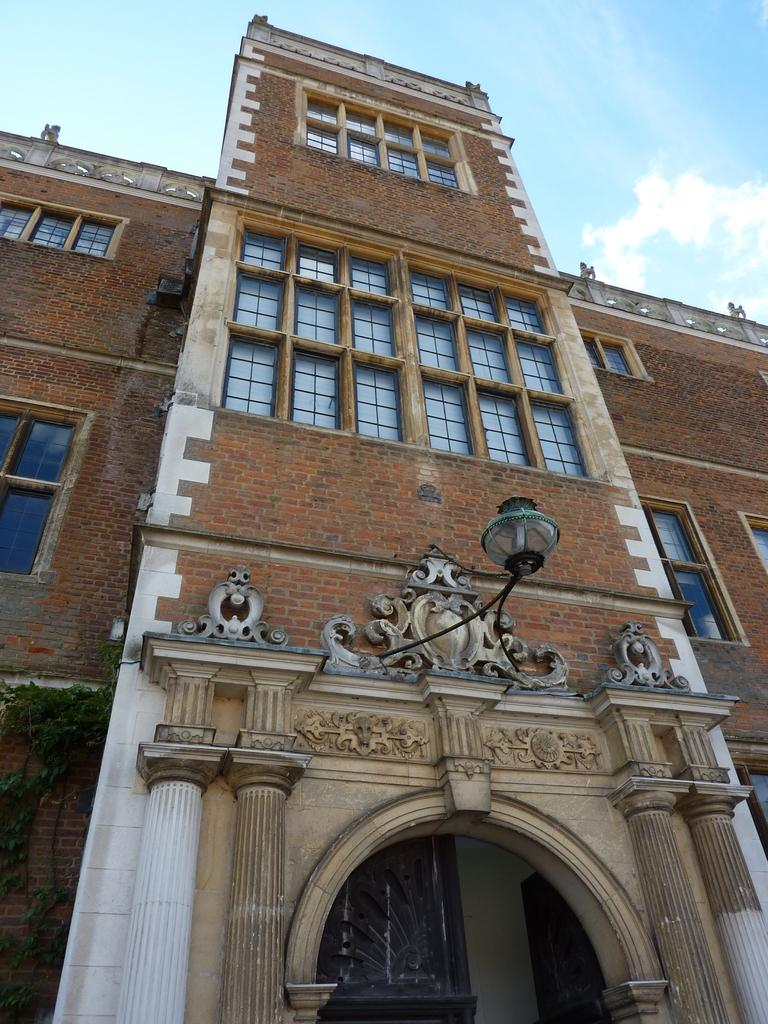What is the main structure in the middle of the image? There is a building in the middle of the image. What can be seen at the bottom of the image? There is a light and an arch at the bottom of the image. What is visible in the sky at the top of the image? There are clouds visible at the top of the image, and the sky is also visible. What type of mitten is being used to hold the clouds in the image? There is no mitten present in the image, and the clouds are not being held by any object. What type of silk fabric is draped over the building in the image? There is no silk fabric present in the image; the building is not covered by any fabric. 